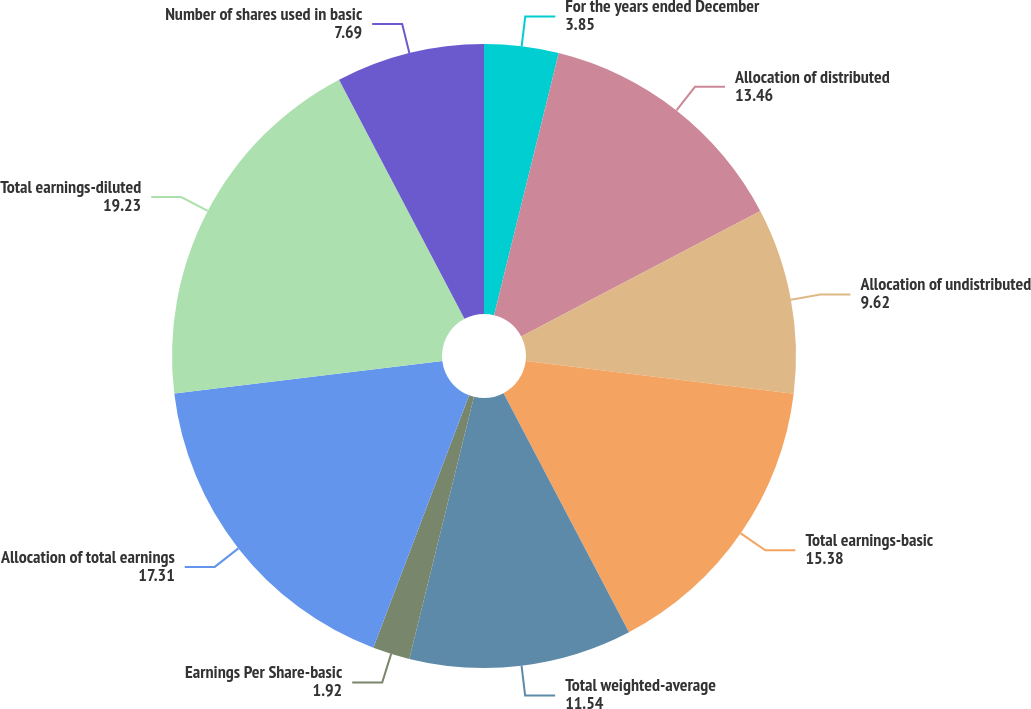<chart> <loc_0><loc_0><loc_500><loc_500><pie_chart><fcel>For the years ended December<fcel>Allocation of distributed<fcel>Allocation of undistributed<fcel>Total earnings-basic<fcel>Total weighted-average<fcel>Earnings Per Share-basic<fcel>Allocation of total earnings<fcel>Total earnings-diluted<fcel>Number of shares used in basic<nl><fcel>3.85%<fcel>13.46%<fcel>9.62%<fcel>15.38%<fcel>11.54%<fcel>1.92%<fcel>17.31%<fcel>19.23%<fcel>7.69%<nl></chart> 